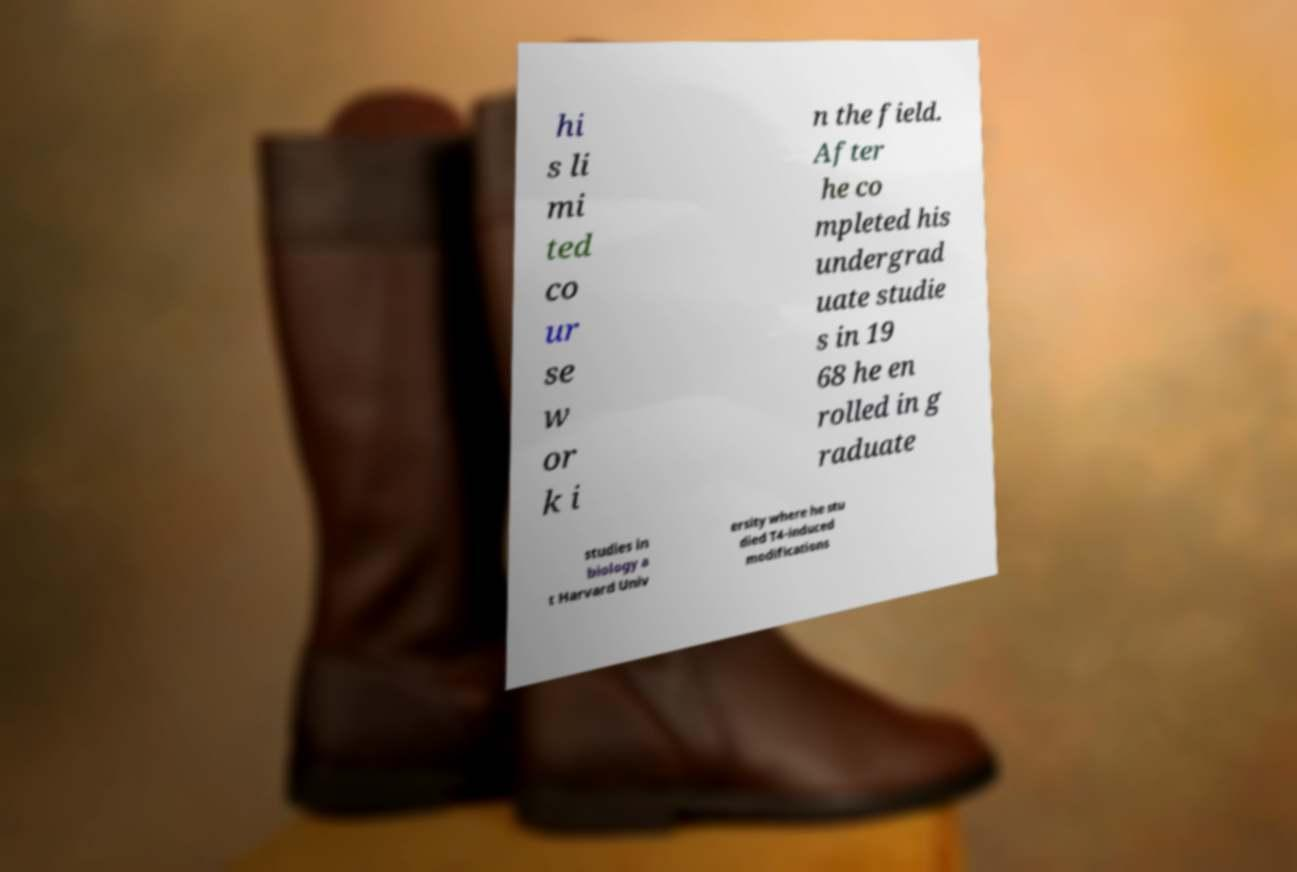For documentation purposes, I need the text within this image transcribed. Could you provide that? hi s li mi ted co ur se w or k i n the field. After he co mpleted his undergrad uate studie s in 19 68 he en rolled in g raduate studies in biology a t Harvard Univ ersity where he stu died T4-induced modifications 